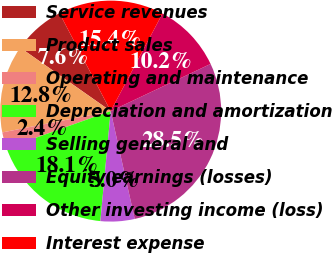Convert chart to OTSL. <chart><loc_0><loc_0><loc_500><loc_500><pie_chart><fcel>Service revenues<fcel>Product sales<fcel>Operating and maintenance<fcel>Depreciation and amortization<fcel>Selling general and<fcel>Equity earnings (losses)<fcel>Other investing income (loss)<fcel>Interest expense<nl><fcel>7.59%<fcel>12.83%<fcel>2.36%<fcel>18.06%<fcel>4.98%<fcel>28.53%<fcel>10.21%<fcel>15.44%<nl></chart> 